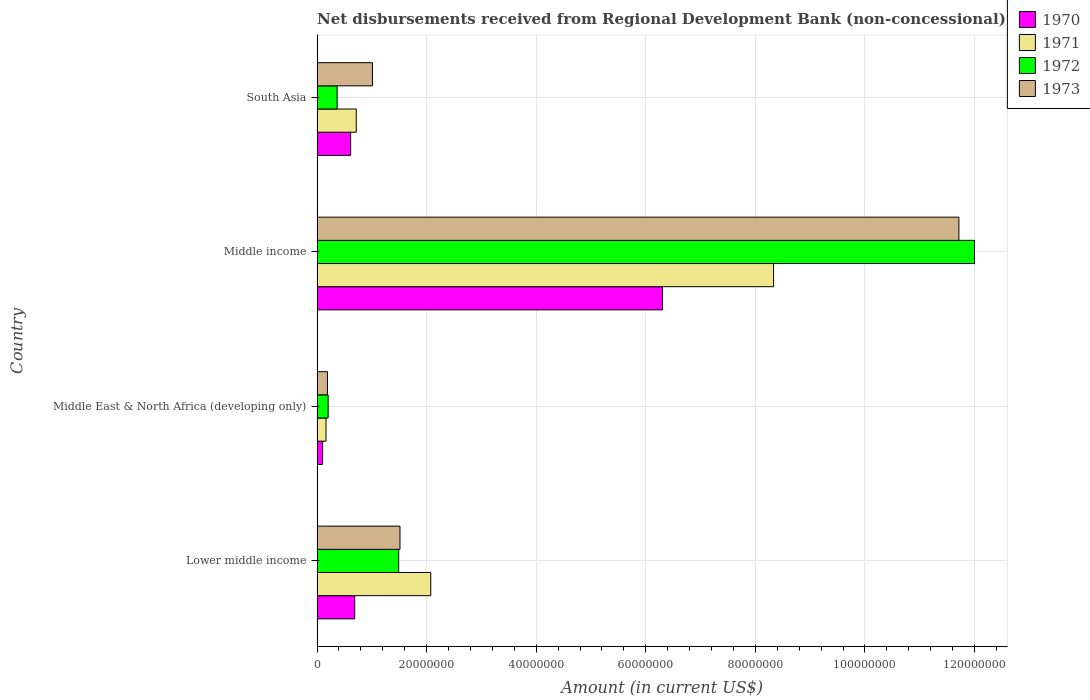Are the number of bars on each tick of the Y-axis equal?
Ensure brevity in your answer.  Yes. How many bars are there on the 1st tick from the bottom?
Offer a terse response. 4. What is the label of the 3rd group of bars from the top?
Offer a very short reply. Middle East & North Africa (developing only). In how many cases, is the number of bars for a given country not equal to the number of legend labels?
Offer a terse response. 0. What is the amount of disbursements received from Regional Development Bank in 1970 in Middle income?
Offer a terse response. 6.31e+07. Across all countries, what is the maximum amount of disbursements received from Regional Development Bank in 1973?
Provide a succinct answer. 1.17e+08. Across all countries, what is the minimum amount of disbursements received from Regional Development Bank in 1971?
Your answer should be compact. 1.64e+06. In which country was the amount of disbursements received from Regional Development Bank in 1973 minimum?
Your answer should be very brief. Middle East & North Africa (developing only). What is the total amount of disbursements received from Regional Development Bank in 1970 in the graph?
Your response must be concise. 7.71e+07. What is the difference between the amount of disbursements received from Regional Development Bank in 1970 in Lower middle income and that in Middle income?
Your answer should be compact. -5.62e+07. What is the difference between the amount of disbursements received from Regional Development Bank in 1972 in Middle income and the amount of disbursements received from Regional Development Bank in 1970 in Middle East & North Africa (developing only)?
Make the answer very short. 1.19e+08. What is the average amount of disbursements received from Regional Development Bank in 1973 per country?
Offer a terse response. 3.61e+07. What is the difference between the amount of disbursements received from Regional Development Bank in 1970 and amount of disbursements received from Regional Development Bank in 1972 in South Asia?
Keep it short and to the point. 2.46e+06. In how many countries, is the amount of disbursements received from Regional Development Bank in 1972 greater than 20000000 US$?
Give a very brief answer. 1. What is the ratio of the amount of disbursements received from Regional Development Bank in 1973 in Middle East & North Africa (developing only) to that in Middle income?
Offer a terse response. 0.02. Is the amount of disbursements received from Regional Development Bank in 1972 in Lower middle income less than that in South Asia?
Ensure brevity in your answer.  No. Is the difference between the amount of disbursements received from Regional Development Bank in 1970 in Lower middle income and Middle East & North Africa (developing only) greater than the difference between the amount of disbursements received from Regional Development Bank in 1972 in Lower middle income and Middle East & North Africa (developing only)?
Give a very brief answer. No. What is the difference between the highest and the second highest amount of disbursements received from Regional Development Bank in 1971?
Make the answer very short. 6.26e+07. What is the difference between the highest and the lowest amount of disbursements received from Regional Development Bank in 1972?
Keep it short and to the point. 1.18e+08. In how many countries, is the amount of disbursements received from Regional Development Bank in 1971 greater than the average amount of disbursements received from Regional Development Bank in 1971 taken over all countries?
Your response must be concise. 1. Is the sum of the amount of disbursements received from Regional Development Bank in 1971 in Middle East & North Africa (developing only) and South Asia greater than the maximum amount of disbursements received from Regional Development Bank in 1970 across all countries?
Your answer should be very brief. No. What does the 2nd bar from the top in South Asia represents?
Provide a succinct answer. 1972. What does the 3rd bar from the bottom in Middle East & North Africa (developing only) represents?
Your response must be concise. 1972. How many bars are there?
Your answer should be compact. 16. Are all the bars in the graph horizontal?
Your answer should be very brief. Yes. Are the values on the major ticks of X-axis written in scientific E-notation?
Your response must be concise. No. Does the graph contain any zero values?
Ensure brevity in your answer.  No. Where does the legend appear in the graph?
Provide a succinct answer. Top right. How many legend labels are there?
Give a very brief answer. 4. How are the legend labels stacked?
Make the answer very short. Vertical. What is the title of the graph?
Offer a terse response. Net disbursements received from Regional Development Bank (non-concessional). What is the label or title of the Y-axis?
Provide a succinct answer. Country. What is the Amount (in current US$) in 1970 in Lower middle income?
Ensure brevity in your answer.  6.87e+06. What is the Amount (in current US$) in 1971 in Lower middle income?
Provide a succinct answer. 2.08e+07. What is the Amount (in current US$) of 1972 in Lower middle income?
Offer a terse response. 1.49e+07. What is the Amount (in current US$) of 1973 in Lower middle income?
Your response must be concise. 1.51e+07. What is the Amount (in current US$) in 1970 in Middle East & North Africa (developing only)?
Your answer should be compact. 1.02e+06. What is the Amount (in current US$) in 1971 in Middle East & North Africa (developing only)?
Keep it short and to the point. 1.64e+06. What is the Amount (in current US$) in 1972 in Middle East & North Africa (developing only)?
Provide a succinct answer. 2.02e+06. What is the Amount (in current US$) of 1973 in Middle East & North Africa (developing only)?
Your answer should be compact. 1.90e+06. What is the Amount (in current US$) in 1970 in Middle income?
Keep it short and to the point. 6.31e+07. What is the Amount (in current US$) in 1971 in Middle income?
Keep it short and to the point. 8.33e+07. What is the Amount (in current US$) in 1972 in Middle income?
Offer a terse response. 1.20e+08. What is the Amount (in current US$) of 1973 in Middle income?
Keep it short and to the point. 1.17e+08. What is the Amount (in current US$) in 1970 in South Asia?
Give a very brief answer. 6.13e+06. What is the Amount (in current US$) in 1971 in South Asia?
Provide a succinct answer. 7.16e+06. What is the Amount (in current US$) in 1972 in South Asia?
Ensure brevity in your answer.  3.67e+06. What is the Amount (in current US$) of 1973 in South Asia?
Provide a short and direct response. 1.01e+07. Across all countries, what is the maximum Amount (in current US$) in 1970?
Keep it short and to the point. 6.31e+07. Across all countries, what is the maximum Amount (in current US$) in 1971?
Make the answer very short. 8.33e+07. Across all countries, what is the maximum Amount (in current US$) in 1972?
Give a very brief answer. 1.20e+08. Across all countries, what is the maximum Amount (in current US$) in 1973?
Provide a short and direct response. 1.17e+08. Across all countries, what is the minimum Amount (in current US$) of 1970?
Offer a terse response. 1.02e+06. Across all countries, what is the minimum Amount (in current US$) in 1971?
Make the answer very short. 1.64e+06. Across all countries, what is the minimum Amount (in current US$) in 1972?
Your answer should be compact. 2.02e+06. Across all countries, what is the minimum Amount (in current US$) of 1973?
Make the answer very short. 1.90e+06. What is the total Amount (in current US$) in 1970 in the graph?
Provide a succinct answer. 7.71e+07. What is the total Amount (in current US$) in 1971 in the graph?
Keep it short and to the point. 1.13e+08. What is the total Amount (in current US$) of 1972 in the graph?
Ensure brevity in your answer.  1.41e+08. What is the total Amount (in current US$) of 1973 in the graph?
Give a very brief answer. 1.44e+08. What is the difference between the Amount (in current US$) of 1970 in Lower middle income and that in Middle East & North Africa (developing only)?
Ensure brevity in your answer.  5.85e+06. What is the difference between the Amount (in current US$) of 1971 in Lower middle income and that in Middle East & North Africa (developing only)?
Offer a terse response. 1.91e+07. What is the difference between the Amount (in current US$) in 1972 in Lower middle income and that in Middle East & North Africa (developing only)?
Provide a short and direct response. 1.29e+07. What is the difference between the Amount (in current US$) of 1973 in Lower middle income and that in Middle East & North Africa (developing only)?
Offer a very short reply. 1.32e+07. What is the difference between the Amount (in current US$) in 1970 in Lower middle income and that in Middle income?
Ensure brevity in your answer.  -5.62e+07. What is the difference between the Amount (in current US$) in 1971 in Lower middle income and that in Middle income?
Provide a succinct answer. -6.26e+07. What is the difference between the Amount (in current US$) of 1972 in Lower middle income and that in Middle income?
Give a very brief answer. -1.05e+08. What is the difference between the Amount (in current US$) in 1973 in Lower middle income and that in Middle income?
Your answer should be compact. -1.02e+08. What is the difference between the Amount (in current US$) of 1970 in Lower middle income and that in South Asia?
Your answer should be very brief. 7.37e+05. What is the difference between the Amount (in current US$) in 1971 in Lower middle income and that in South Asia?
Your answer should be compact. 1.36e+07. What is the difference between the Amount (in current US$) in 1972 in Lower middle income and that in South Asia?
Give a very brief answer. 1.12e+07. What is the difference between the Amount (in current US$) of 1973 in Lower middle income and that in South Asia?
Your answer should be very brief. 5.02e+06. What is the difference between the Amount (in current US$) in 1970 in Middle East & North Africa (developing only) and that in Middle income?
Give a very brief answer. -6.20e+07. What is the difference between the Amount (in current US$) in 1971 in Middle East & North Africa (developing only) and that in Middle income?
Give a very brief answer. -8.17e+07. What is the difference between the Amount (in current US$) in 1972 in Middle East & North Africa (developing only) and that in Middle income?
Your answer should be compact. -1.18e+08. What is the difference between the Amount (in current US$) in 1973 in Middle East & North Africa (developing only) and that in Middle income?
Offer a terse response. -1.15e+08. What is the difference between the Amount (in current US$) of 1970 in Middle East & North Africa (developing only) and that in South Asia?
Offer a terse response. -5.11e+06. What is the difference between the Amount (in current US$) of 1971 in Middle East & North Africa (developing only) and that in South Asia?
Make the answer very short. -5.52e+06. What is the difference between the Amount (in current US$) of 1972 in Middle East & North Africa (developing only) and that in South Asia?
Give a very brief answer. -1.64e+06. What is the difference between the Amount (in current US$) of 1973 in Middle East & North Africa (developing only) and that in South Asia?
Provide a short and direct response. -8.22e+06. What is the difference between the Amount (in current US$) in 1970 in Middle income and that in South Asia?
Your response must be concise. 5.69e+07. What is the difference between the Amount (in current US$) in 1971 in Middle income and that in South Asia?
Ensure brevity in your answer.  7.62e+07. What is the difference between the Amount (in current US$) of 1972 in Middle income and that in South Asia?
Make the answer very short. 1.16e+08. What is the difference between the Amount (in current US$) of 1973 in Middle income and that in South Asia?
Your response must be concise. 1.07e+08. What is the difference between the Amount (in current US$) of 1970 in Lower middle income and the Amount (in current US$) of 1971 in Middle East & North Africa (developing only)?
Your response must be concise. 5.24e+06. What is the difference between the Amount (in current US$) of 1970 in Lower middle income and the Amount (in current US$) of 1972 in Middle East & North Africa (developing only)?
Keep it short and to the point. 4.85e+06. What is the difference between the Amount (in current US$) in 1970 in Lower middle income and the Amount (in current US$) in 1973 in Middle East & North Africa (developing only)?
Provide a succinct answer. 4.98e+06. What is the difference between the Amount (in current US$) of 1971 in Lower middle income and the Amount (in current US$) of 1972 in Middle East & North Africa (developing only)?
Provide a short and direct response. 1.87e+07. What is the difference between the Amount (in current US$) in 1971 in Lower middle income and the Amount (in current US$) in 1973 in Middle East & North Africa (developing only)?
Your response must be concise. 1.89e+07. What is the difference between the Amount (in current US$) of 1972 in Lower middle income and the Amount (in current US$) of 1973 in Middle East & North Africa (developing only)?
Provide a succinct answer. 1.30e+07. What is the difference between the Amount (in current US$) of 1970 in Lower middle income and the Amount (in current US$) of 1971 in Middle income?
Your response must be concise. -7.65e+07. What is the difference between the Amount (in current US$) in 1970 in Lower middle income and the Amount (in current US$) in 1972 in Middle income?
Make the answer very short. -1.13e+08. What is the difference between the Amount (in current US$) of 1970 in Lower middle income and the Amount (in current US$) of 1973 in Middle income?
Ensure brevity in your answer.  -1.10e+08. What is the difference between the Amount (in current US$) of 1971 in Lower middle income and the Amount (in current US$) of 1972 in Middle income?
Offer a terse response. -9.92e+07. What is the difference between the Amount (in current US$) of 1971 in Lower middle income and the Amount (in current US$) of 1973 in Middle income?
Your answer should be very brief. -9.64e+07. What is the difference between the Amount (in current US$) in 1972 in Lower middle income and the Amount (in current US$) in 1973 in Middle income?
Ensure brevity in your answer.  -1.02e+08. What is the difference between the Amount (in current US$) in 1970 in Lower middle income and the Amount (in current US$) in 1971 in South Asia?
Ensure brevity in your answer.  -2.87e+05. What is the difference between the Amount (in current US$) of 1970 in Lower middle income and the Amount (in current US$) of 1972 in South Asia?
Make the answer very short. 3.20e+06. What is the difference between the Amount (in current US$) in 1970 in Lower middle income and the Amount (in current US$) in 1973 in South Asia?
Ensure brevity in your answer.  -3.24e+06. What is the difference between the Amount (in current US$) in 1971 in Lower middle income and the Amount (in current US$) in 1972 in South Asia?
Offer a very short reply. 1.71e+07. What is the difference between the Amount (in current US$) of 1971 in Lower middle income and the Amount (in current US$) of 1973 in South Asia?
Offer a terse response. 1.06e+07. What is the difference between the Amount (in current US$) in 1972 in Lower middle income and the Amount (in current US$) in 1973 in South Asia?
Give a very brief answer. 4.78e+06. What is the difference between the Amount (in current US$) in 1970 in Middle East & North Africa (developing only) and the Amount (in current US$) in 1971 in Middle income?
Offer a terse response. -8.23e+07. What is the difference between the Amount (in current US$) in 1970 in Middle East & North Africa (developing only) and the Amount (in current US$) in 1972 in Middle income?
Give a very brief answer. -1.19e+08. What is the difference between the Amount (in current US$) in 1970 in Middle East & North Africa (developing only) and the Amount (in current US$) in 1973 in Middle income?
Provide a short and direct response. -1.16e+08. What is the difference between the Amount (in current US$) of 1971 in Middle East & North Africa (developing only) and the Amount (in current US$) of 1972 in Middle income?
Your answer should be compact. -1.18e+08. What is the difference between the Amount (in current US$) of 1971 in Middle East & North Africa (developing only) and the Amount (in current US$) of 1973 in Middle income?
Give a very brief answer. -1.16e+08. What is the difference between the Amount (in current US$) of 1972 in Middle East & North Africa (developing only) and the Amount (in current US$) of 1973 in Middle income?
Keep it short and to the point. -1.15e+08. What is the difference between the Amount (in current US$) in 1970 in Middle East & North Africa (developing only) and the Amount (in current US$) in 1971 in South Asia?
Offer a very short reply. -6.14e+06. What is the difference between the Amount (in current US$) in 1970 in Middle East & North Africa (developing only) and the Amount (in current US$) in 1972 in South Asia?
Give a very brief answer. -2.65e+06. What is the difference between the Amount (in current US$) in 1970 in Middle East & North Africa (developing only) and the Amount (in current US$) in 1973 in South Asia?
Give a very brief answer. -9.09e+06. What is the difference between the Amount (in current US$) in 1971 in Middle East & North Africa (developing only) and the Amount (in current US$) in 1972 in South Asia?
Your answer should be very brief. -2.03e+06. What is the difference between the Amount (in current US$) in 1971 in Middle East & North Africa (developing only) and the Amount (in current US$) in 1973 in South Asia?
Your response must be concise. -8.48e+06. What is the difference between the Amount (in current US$) of 1972 in Middle East & North Africa (developing only) and the Amount (in current US$) of 1973 in South Asia?
Your answer should be compact. -8.09e+06. What is the difference between the Amount (in current US$) in 1970 in Middle income and the Amount (in current US$) in 1971 in South Asia?
Provide a short and direct response. 5.59e+07. What is the difference between the Amount (in current US$) in 1970 in Middle income and the Amount (in current US$) in 1972 in South Asia?
Provide a short and direct response. 5.94e+07. What is the difference between the Amount (in current US$) in 1970 in Middle income and the Amount (in current US$) in 1973 in South Asia?
Make the answer very short. 5.29e+07. What is the difference between the Amount (in current US$) of 1971 in Middle income and the Amount (in current US$) of 1972 in South Asia?
Offer a terse response. 7.97e+07. What is the difference between the Amount (in current US$) in 1971 in Middle income and the Amount (in current US$) in 1973 in South Asia?
Offer a terse response. 7.32e+07. What is the difference between the Amount (in current US$) of 1972 in Middle income and the Amount (in current US$) of 1973 in South Asia?
Make the answer very short. 1.10e+08. What is the average Amount (in current US$) of 1970 per country?
Keep it short and to the point. 1.93e+07. What is the average Amount (in current US$) of 1971 per country?
Offer a very short reply. 2.82e+07. What is the average Amount (in current US$) of 1972 per country?
Your response must be concise. 3.51e+07. What is the average Amount (in current US$) of 1973 per country?
Provide a succinct answer. 3.61e+07. What is the difference between the Amount (in current US$) of 1970 and Amount (in current US$) of 1971 in Lower middle income?
Your answer should be compact. -1.39e+07. What is the difference between the Amount (in current US$) in 1970 and Amount (in current US$) in 1972 in Lower middle income?
Ensure brevity in your answer.  -8.03e+06. What is the difference between the Amount (in current US$) in 1970 and Amount (in current US$) in 1973 in Lower middle income?
Your answer should be very brief. -8.26e+06. What is the difference between the Amount (in current US$) in 1971 and Amount (in current US$) in 1972 in Lower middle income?
Give a very brief answer. 5.85e+06. What is the difference between the Amount (in current US$) of 1971 and Amount (in current US$) of 1973 in Lower middle income?
Give a very brief answer. 5.62e+06. What is the difference between the Amount (in current US$) of 1972 and Amount (in current US$) of 1973 in Lower middle income?
Ensure brevity in your answer.  -2.36e+05. What is the difference between the Amount (in current US$) in 1970 and Amount (in current US$) in 1971 in Middle East & North Africa (developing only)?
Your answer should be compact. -6.14e+05. What is the difference between the Amount (in current US$) in 1970 and Amount (in current US$) in 1972 in Middle East & North Africa (developing only)?
Offer a terse response. -1.00e+06. What is the difference between the Amount (in current US$) of 1970 and Amount (in current US$) of 1973 in Middle East & North Africa (developing only)?
Offer a very short reply. -8.75e+05. What is the difference between the Amount (in current US$) of 1971 and Amount (in current US$) of 1972 in Middle East & North Africa (developing only)?
Offer a very short reply. -3.89e+05. What is the difference between the Amount (in current US$) in 1971 and Amount (in current US$) in 1973 in Middle East & North Africa (developing only)?
Offer a terse response. -2.61e+05. What is the difference between the Amount (in current US$) in 1972 and Amount (in current US$) in 1973 in Middle East & North Africa (developing only)?
Provide a succinct answer. 1.28e+05. What is the difference between the Amount (in current US$) in 1970 and Amount (in current US$) in 1971 in Middle income?
Give a very brief answer. -2.03e+07. What is the difference between the Amount (in current US$) of 1970 and Amount (in current US$) of 1972 in Middle income?
Your answer should be very brief. -5.69e+07. What is the difference between the Amount (in current US$) of 1970 and Amount (in current US$) of 1973 in Middle income?
Ensure brevity in your answer.  -5.41e+07. What is the difference between the Amount (in current US$) of 1971 and Amount (in current US$) of 1972 in Middle income?
Your response must be concise. -3.67e+07. What is the difference between the Amount (in current US$) of 1971 and Amount (in current US$) of 1973 in Middle income?
Keep it short and to the point. -3.38e+07. What is the difference between the Amount (in current US$) of 1972 and Amount (in current US$) of 1973 in Middle income?
Keep it short and to the point. 2.85e+06. What is the difference between the Amount (in current US$) in 1970 and Amount (in current US$) in 1971 in South Asia?
Your answer should be very brief. -1.02e+06. What is the difference between the Amount (in current US$) in 1970 and Amount (in current US$) in 1972 in South Asia?
Your answer should be very brief. 2.46e+06. What is the difference between the Amount (in current US$) in 1970 and Amount (in current US$) in 1973 in South Asia?
Keep it short and to the point. -3.98e+06. What is the difference between the Amount (in current US$) of 1971 and Amount (in current US$) of 1972 in South Asia?
Give a very brief answer. 3.49e+06. What is the difference between the Amount (in current US$) of 1971 and Amount (in current US$) of 1973 in South Asia?
Offer a terse response. -2.95e+06. What is the difference between the Amount (in current US$) in 1972 and Amount (in current US$) in 1973 in South Asia?
Offer a terse response. -6.44e+06. What is the ratio of the Amount (in current US$) in 1970 in Lower middle income to that in Middle East & North Africa (developing only)?
Your response must be concise. 6.73. What is the ratio of the Amount (in current US$) of 1971 in Lower middle income to that in Middle East & North Africa (developing only)?
Make the answer very short. 12.69. What is the ratio of the Amount (in current US$) in 1972 in Lower middle income to that in Middle East & North Africa (developing only)?
Your response must be concise. 7.36. What is the ratio of the Amount (in current US$) of 1973 in Lower middle income to that in Middle East & North Africa (developing only)?
Make the answer very short. 7.98. What is the ratio of the Amount (in current US$) of 1970 in Lower middle income to that in Middle income?
Provide a short and direct response. 0.11. What is the ratio of the Amount (in current US$) in 1971 in Lower middle income to that in Middle income?
Provide a succinct answer. 0.25. What is the ratio of the Amount (in current US$) in 1972 in Lower middle income to that in Middle income?
Offer a terse response. 0.12. What is the ratio of the Amount (in current US$) in 1973 in Lower middle income to that in Middle income?
Provide a succinct answer. 0.13. What is the ratio of the Amount (in current US$) of 1970 in Lower middle income to that in South Asia?
Offer a very short reply. 1.12. What is the ratio of the Amount (in current US$) of 1971 in Lower middle income to that in South Asia?
Keep it short and to the point. 2.9. What is the ratio of the Amount (in current US$) of 1972 in Lower middle income to that in South Asia?
Provide a short and direct response. 4.06. What is the ratio of the Amount (in current US$) in 1973 in Lower middle income to that in South Asia?
Make the answer very short. 1.5. What is the ratio of the Amount (in current US$) in 1970 in Middle East & North Africa (developing only) to that in Middle income?
Your response must be concise. 0.02. What is the ratio of the Amount (in current US$) of 1971 in Middle East & North Africa (developing only) to that in Middle income?
Your answer should be compact. 0.02. What is the ratio of the Amount (in current US$) in 1972 in Middle East & North Africa (developing only) to that in Middle income?
Give a very brief answer. 0.02. What is the ratio of the Amount (in current US$) of 1973 in Middle East & North Africa (developing only) to that in Middle income?
Provide a short and direct response. 0.02. What is the ratio of the Amount (in current US$) in 1970 in Middle East & North Africa (developing only) to that in South Asia?
Provide a succinct answer. 0.17. What is the ratio of the Amount (in current US$) in 1971 in Middle East & North Africa (developing only) to that in South Asia?
Make the answer very short. 0.23. What is the ratio of the Amount (in current US$) of 1972 in Middle East & North Africa (developing only) to that in South Asia?
Make the answer very short. 0.55. What is the ratio of the Amount (in current US$) of 1973 in Middle East & North Africa (developing only) to that in South Asia?
Your response must be concise. 0.19. What is the ratio of the Amount (in current US$) of 1970 in Middle income to that in South Asia?
Offer a very short reply. 10.28. What is the ratio of the Amount (in current US$) in 1971 in Middle income to that in South Asia?
Your response must be concise. 11.64. What is the ratio of the Amount (in current US$) of 1972 in Middle income to that in South Asia?
Your answer should be very brief. 32.71. What is the ratio of the Amount (in current US$) of 1973 in Middle income to that in South Asia?
Offer a very short reply. 11.58. What is the difference between the highest and the second highest Amount (in current US$) in 1970?
Keep it short and to the point. 5.62e+07. What is the difference between the highest and the second highest Amount (in current US$) of 1971?
Offer a very short reply. 6.26e+07. What is the difference between the highest and the second highest Amount (in current US$) in 1972?
Keep it short and to the point. 1.05e+08. What is the difference between the highest and the second highest Amount (in current US$) in 1973?
Provide a short and direct response. 1.02e+08. What is the difference between the highest and the lowest Amount (in current US$) of 1970?
Offer a very short reply. 6.20e+07. What is the difference between the highest and the lowest Amount (in current US$) of 1971?
Offer a very short reply. 8.17e+07. What is the difference between the highest and the lowest Amount (in current US$) in 1972?
Make the answer very short. 1.18e+08. What is the difference between the highest and the lowest Amount (in current US$) in 1973?
Your answer should be very brief. 1.15e+08. 